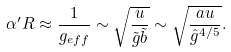Convert formula to latex. <formula><loc_0><loc_0><loc_500><loc_500>\alpha ^ { \prime } R \approx \frac { 1 } { g _ { e f f } } \sim \sqrt { \frac { u } { \tilde { g } \tilde { b } } } \sim \sqrt { \frac { a u } { { \hat { g } } ^ { 4 / 5 } } } .</formula> 